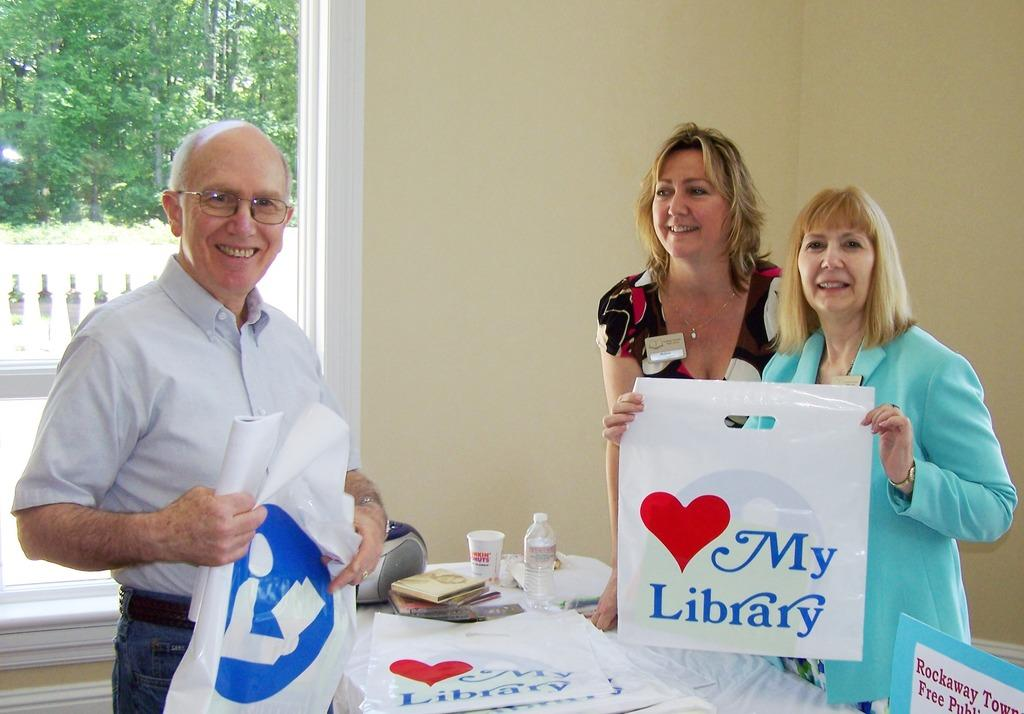<image>
Relay a brief, clear account of the picture shown. The plastic bag the lady is displaying hearts my library. 